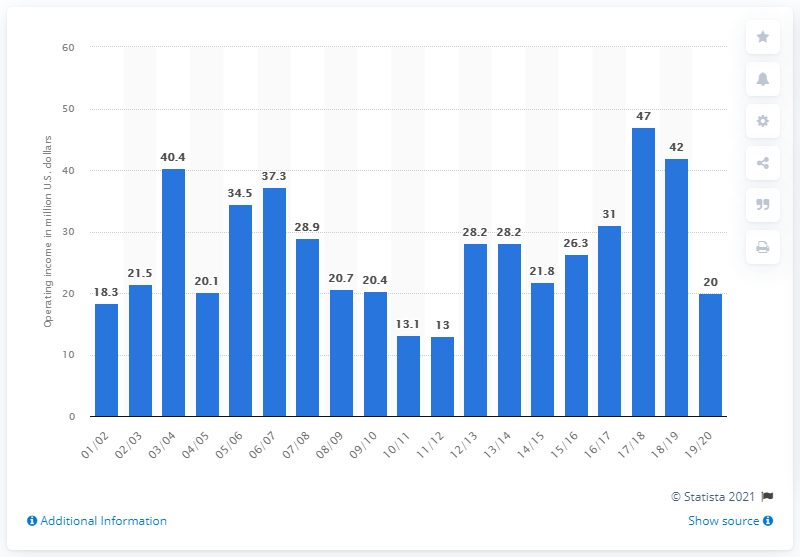Indicate a few pertinent items in this graphic. In the 2019/20 season, the operating income of the Phoenix Suns was X. The operating income of the Phoenix Suns in the 2019/20 season was 20... 